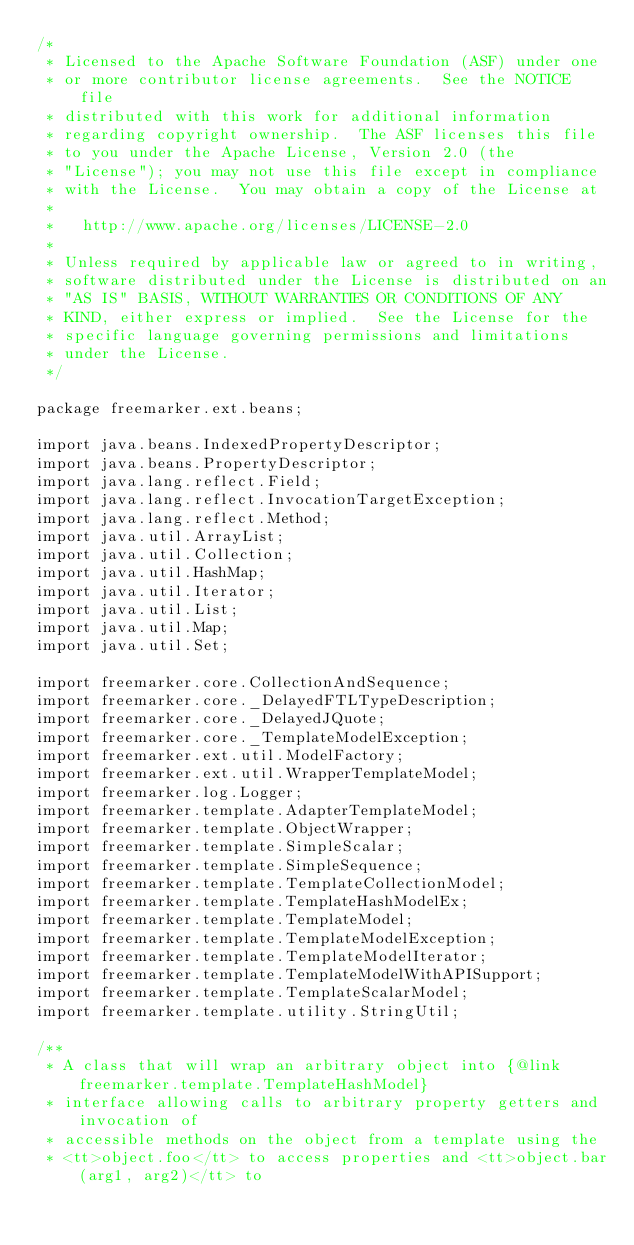<code> <loc_0><loc_0><loc_500><loc_500><_Java_>/*
 * Licensed to the Apache Software Foundation (ASF) under one
 * or more contributor license agreements.  See the NOTICE file
 * distributed with this work for additional information
 * regarding copyright ownership.  The ASF licenses this file
 * to you under the Apache License, Version 2.0 (the
 * "License"); you may not use this file except in compliance
 * with the License.  You may obtain a copy of the License at
 * 
 *   http://www.apache.org/licenses/LICENSE-2.0
 * 
 * Unless required by applicable law or agreed to in writing,
 * software distributed under the License is distributed on an
 * "AS IS" BASIS, WITHOUT WARRANTIES OR CONDITIONS OF ANY
 * KIND, either express or implied.  See the License for the
 * specific language governing permissions and limitations
 * under the License.
 */

package freemarker.ext.beans;

import java.beans.IndexedPropertyDescriptor;
import java.beans.PropertyDescriptor;
import java.lang.reflect.Field;
import java.lang.reflect.InvocationTargetException;
import java.lang.reflect.Method;
import java.util.ArrayList;
import java.util.Collection;
import java.util.HashMap;
import java.util.Iterator;
import java.util.List;
import java.util.Map;
import java.util.Set;

import freemarker.core.CollectionAndSequence;
import freemarker.core._DelayedFTLTypeDescription;
import freemarker.core._DelayedJQuote;
import freemarker.core._TemplateModelException;
import freemarker.ext.util.ModelFactory;
import freemarker.ext.util.WrapperTemplateModel;
import freemarker.log.Logger;
import freemarker.template.AdapterTemplateModel;
import freemarker.template.ObjectWrapper;
import freemarker.template.SimpleScalar;
import freemarker.template.SimpleSequence;
import freemarker.template.TemplateCollectionModel;
import freemarker.template.TemplateHashModelEx;
import freemarker.template.TemplateModel;
import freemarker.template.TemplateModelException;
import freemarker.template.TemplateModelIterator;
import freemarker.template.TemplateModelWithAPISupport;
import freemarker.template.TemplateScalarModel;
import freemarker.template.utility.StringUtil;

/**
 * A class that will wrap an arbitrary object into {@link freemarker.template.TemplateHashModel}
 * interface allowing calls to arbitrary property getters and invocation of
 * accessible methods on the object from a template using the
 * <tt>object.foo</tt> to access properties and <tt>object.bar(arg1, arg2)</tt> to</code> 